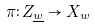<formula> <loc_0><loc_0><loc_500><loc_500>\pi \colon Z _ { \underline { w } } \rightarrow X _ { w }</formula> 